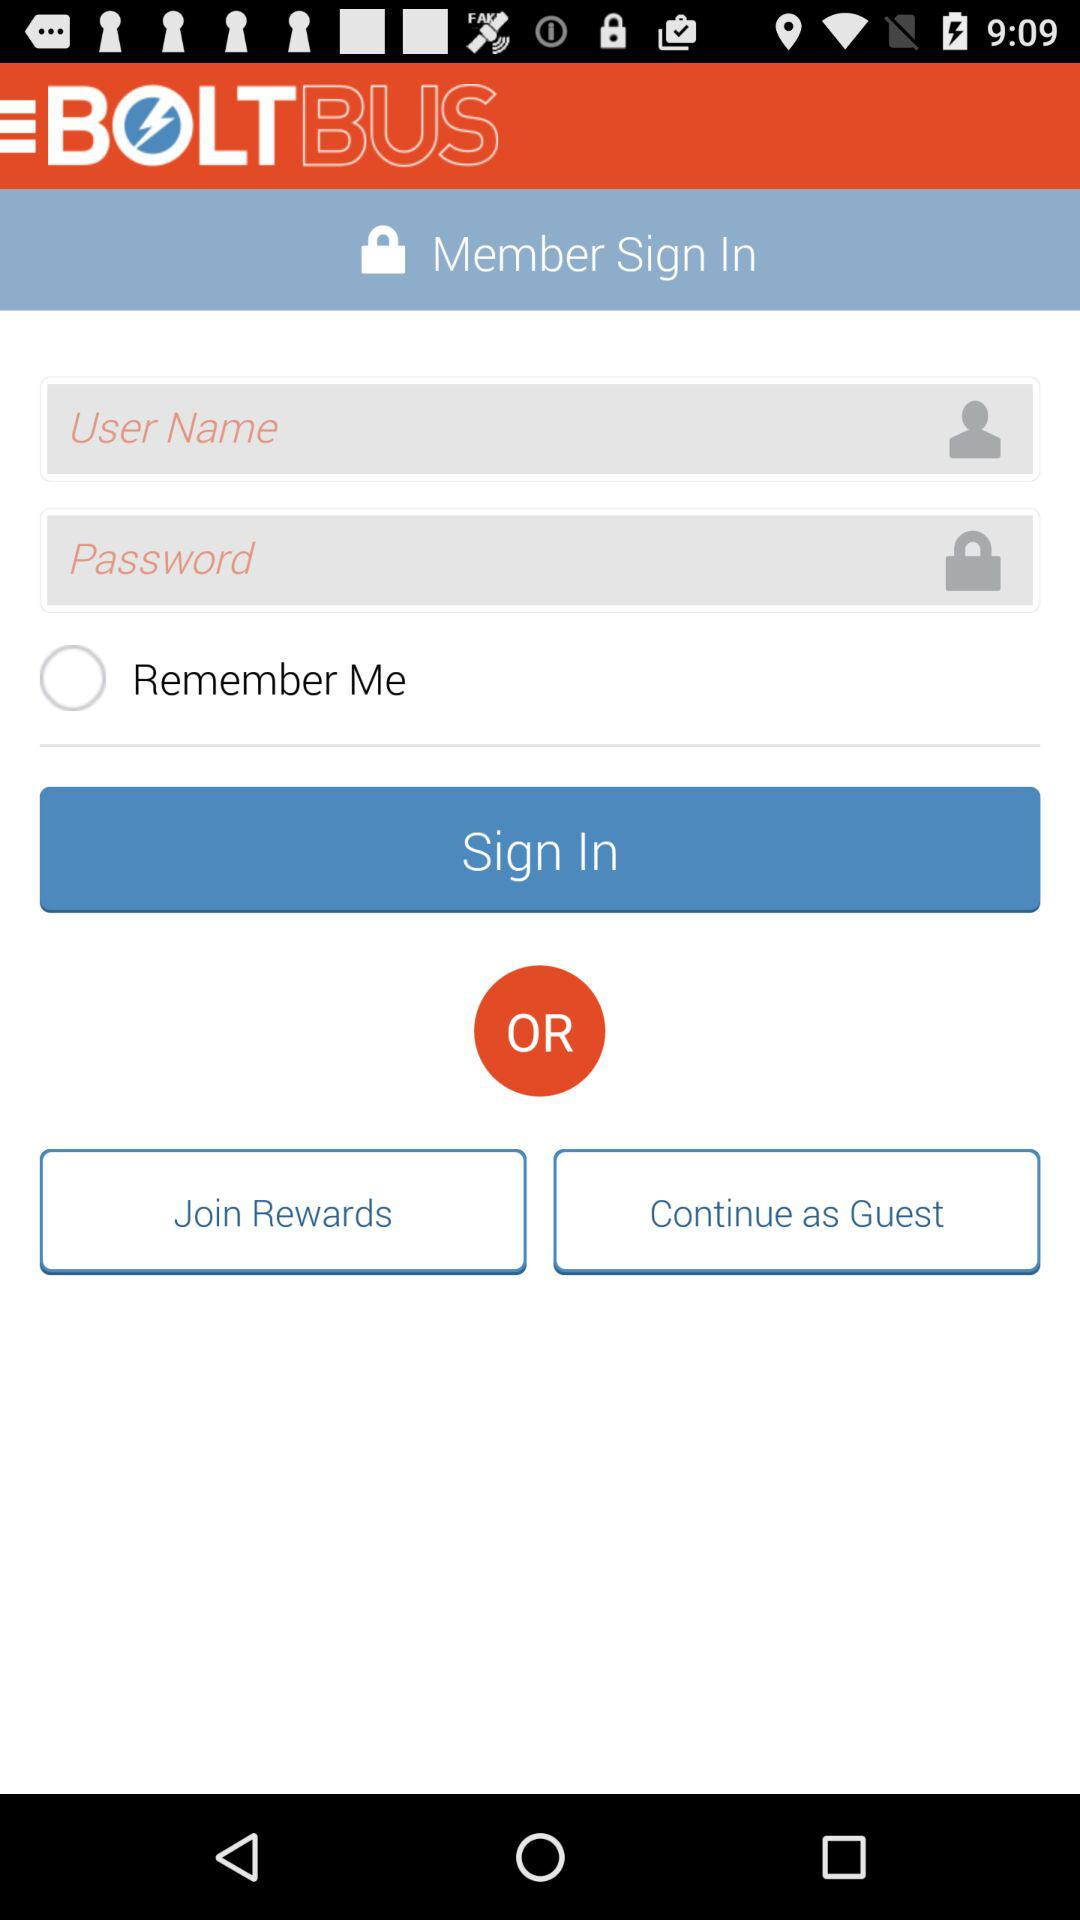What is the current status of the "Remember Me" setting? The current status is "off". 